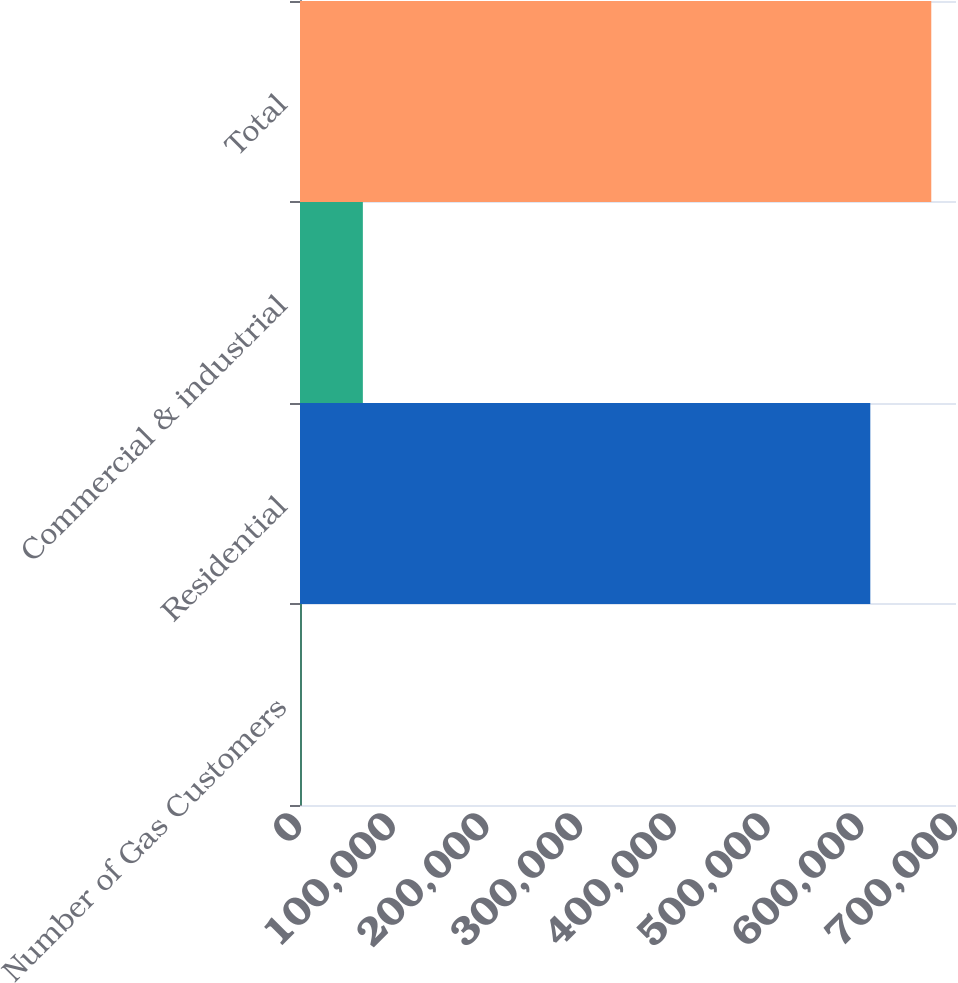Convert chart to OTSL. <chart><loc_0><loc_0><loc_500><loc_500><bar_chart><fcel>Number of Gas Customers<fcel>Residential<fcel>Commercial & industrial<fcel>Total<nl><fcel>2010<fcel>608553<fcel>67068.4<fcel>673611<nl></chart> 